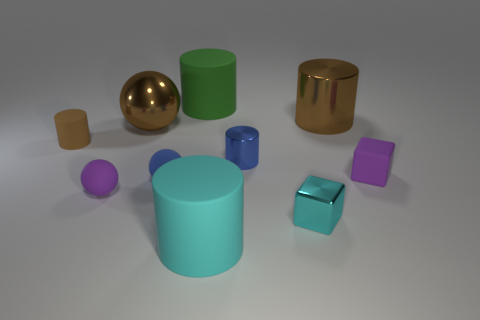Is the cyan matte object the same shape as the blue metal object?
Give a very brief answer. Yes. What is the color of the large matte cylinder in front of the small matte cube that is behind the small purple ball?
Keep it short and to the point. Cyan. The other metallic cylinder that is the same size as the green cylinder is what color?
Provide a succinct answer. Brown. What number of matte objects are small cyan balls or big green cylinders?
Your answer should be very brief. 1. There is a tiny blue object that is in front of the small purple matte block; what number of small cyan things are right of it?
Your answer should be very brief. 1. What is the size of the matte cylinder that is the same color as the metal cube?
Give a very brief answer. Large. How many things are either cyan rubber things or rubber cylinders behind the blue metallic cylinder?
Your answer should be compact. 3. Is there a tiny purple thing made of the same material as the purple cube?
Make the answer very short. Yes. How many things are in front of the rubber block and behind the big brown cylinder?
Provide a succinct answer. 0. What is the material of the brown cylinder behind the tiny brown object?
Keep it short and to the point. Metal. 